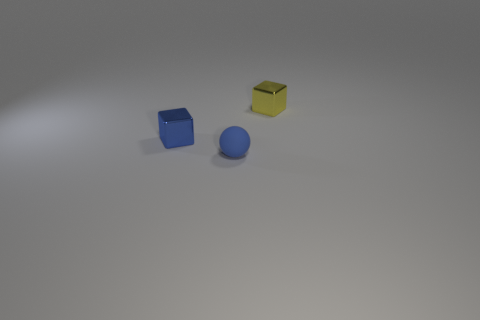There is a blue metallic thing that is the same shape as the yellow object; what is its size?
Provide a short and direct response. Small. How big is the object that is left of the yellow cube and behind the rubber thing?
Keep it short and to the point. Small. There is a small blue ball; are there any small metal blocks to the left of it?
Offer a terse response. Yes. How many things are either blocks that are on the left side of the yellow shiny block or tiny spheres?
Provide a short and direct response. 2. There is a block that is on the right side of the ball; how many blue metallic blocks are in front of it?
Your response must be concise. 1. Is the number of small yellow cubes in front of the blue rubber ball less than the number of blue metallic cubes left of the yellow block?
Give a very brief answer. Yes. The metallic thing on the left side of the small shiny object on the right side of the tiny blue metal block is what shape?
Make the answer very short. Cube. What number of other objects are there of the same material as the blue ball?
Ensure brevity in your answer.  0. Are there more metallic cubes than blue metal cubes?
Offer a very short reply. Yes. Is the number of tiny balls to the left of the small blue block less than the number of large gray metal balls?
Give a very brief answer. No. 